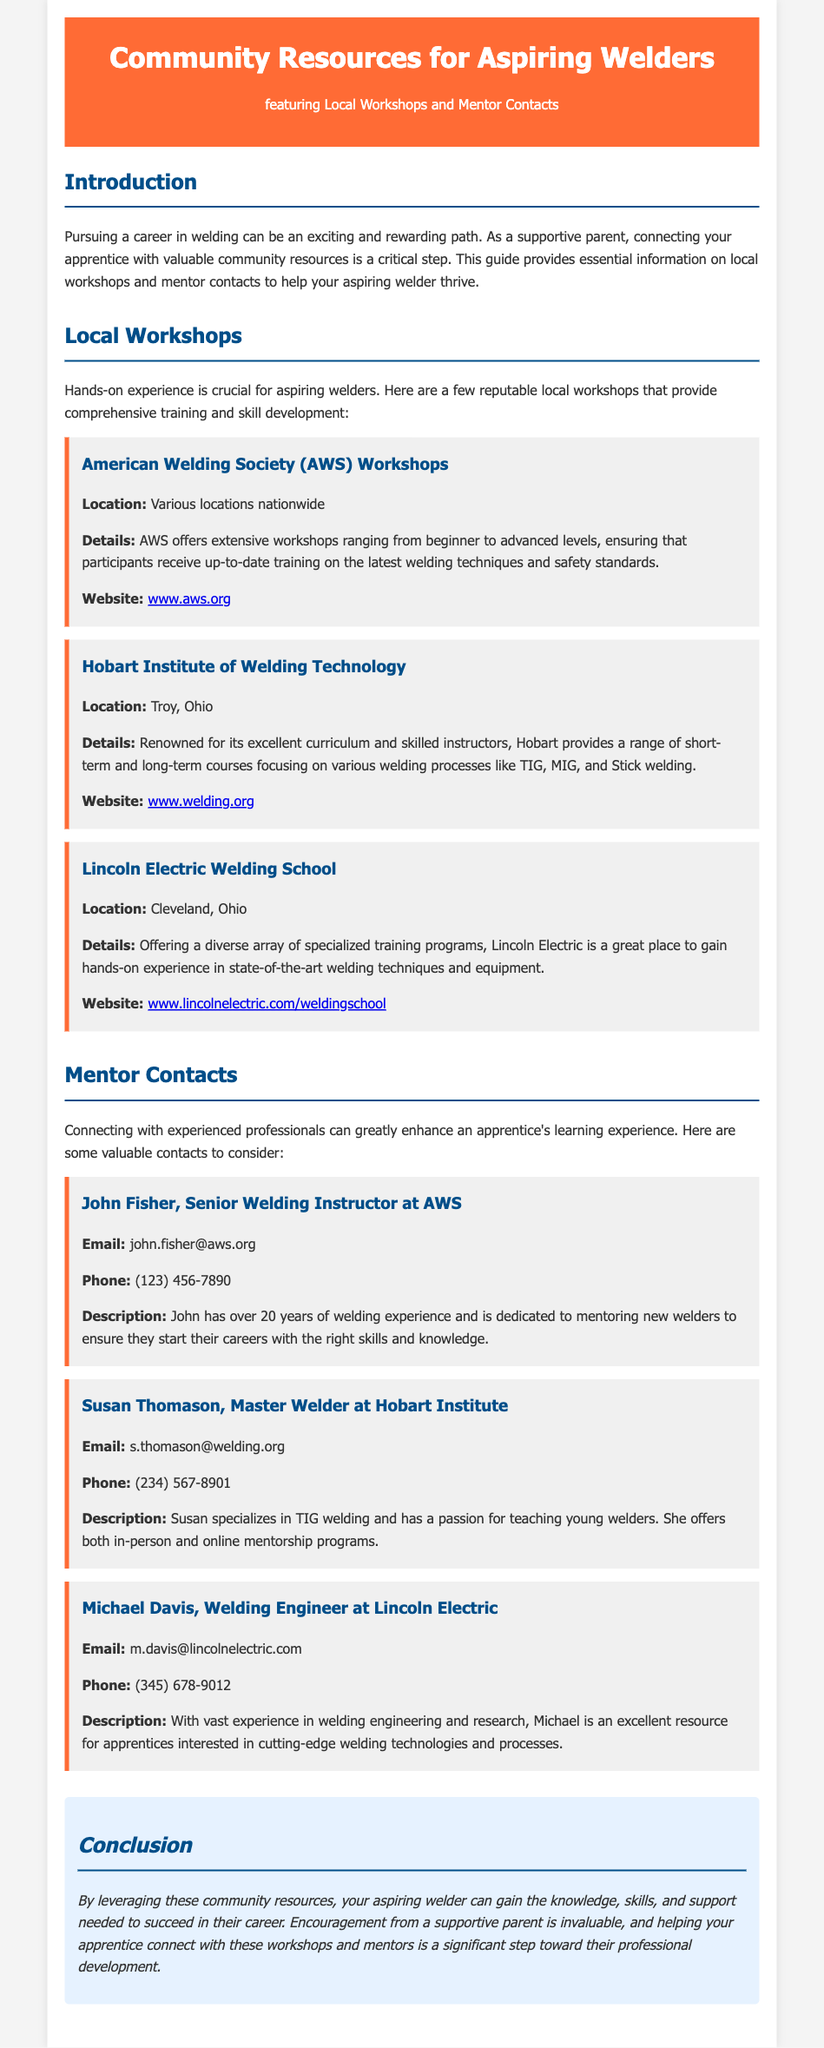What is the title of the document? The title of the document is provided in the header section of the document, which is "Community Resources for Aspiring Welders."
Answer: Community Resources for Aspiring Welders What type of resources does this document provide? The document provides information about workshops and mentors for aspiring welders, as stated in the introduction section.
Answer: Workshops and mentors Who is the author of the workshops listed? The author or sponsor of the workshops is the American Welding Society, indicated in the workshop section.
Answer: American Welding Society What is the location of the Hobart Institute of Welding Technology? The document specifies the location of the Hobart Institute of Welding Technology as "Troy, Ohio."
Answer: Troy, Ohio Which mentor specializes in TIG welding? The document mentions Susan Thomason as a mentor who specializes in TIG welding.
Answer: Susan Thomason How many years of experience does John Fisher have? The document notes that John Fisher has over 20 years of welding experience.
Answer: 20 years What is the conclusion of the document? The conclusion summarizes the importance of community resources for aspiring welders and the role of supportive parents, highlighting the need for skill and mentorship.
Answer: Encouragement from a supportive parent is invaluable What is the phone number of Michael Davis? The document provides the phone number of Michael Davis as "(345) 678-9012."
Answer: (345) 678-9012 